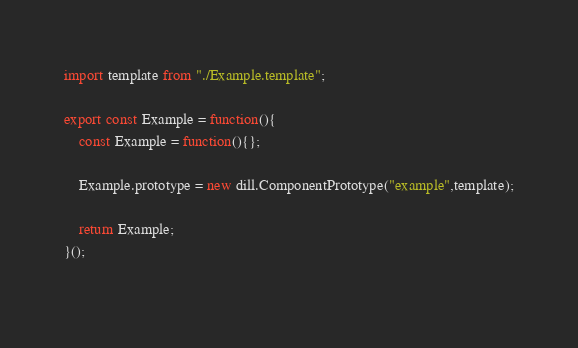<code> <loc_0><loc_0><loc_500><loc_500><_JavaScript_>import template from "./Example.template";

export const Example = function(){
    const Example = function(){};

    Example.prototype = new dill.ComponentPrototype("example",template);

    return Example;
}();
        </code> 